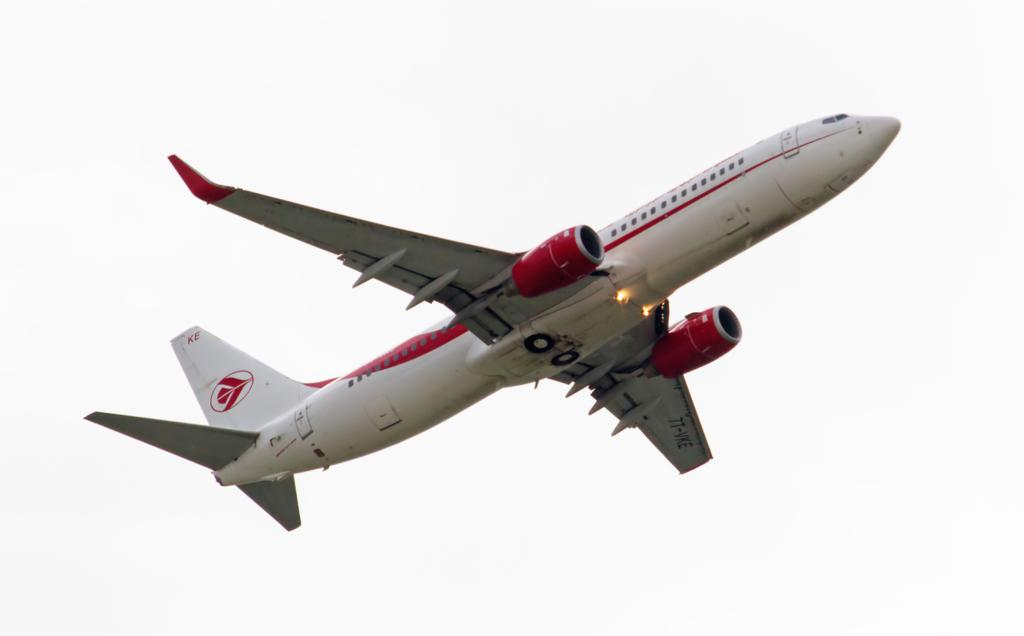What type of aircraft is visible in the image? There is a white aircraft in the image. What is the aircraft doing in the image? The aircraft is flying in the sky. Where is the soap placed on the shelf in the image? There is no soap or shelf present in the image; it only features a white aircraft flying in the sky. 